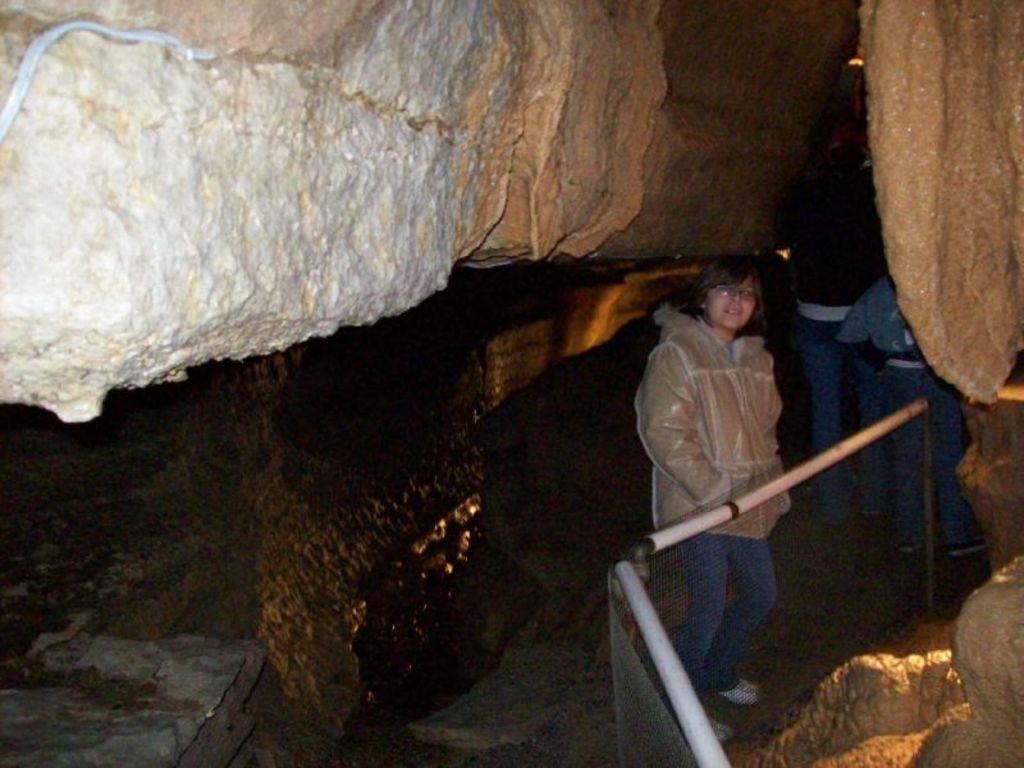How would you summarize this image in a sentence or two? In this image in front there is a metal fence. There are people standing inside the caves. 